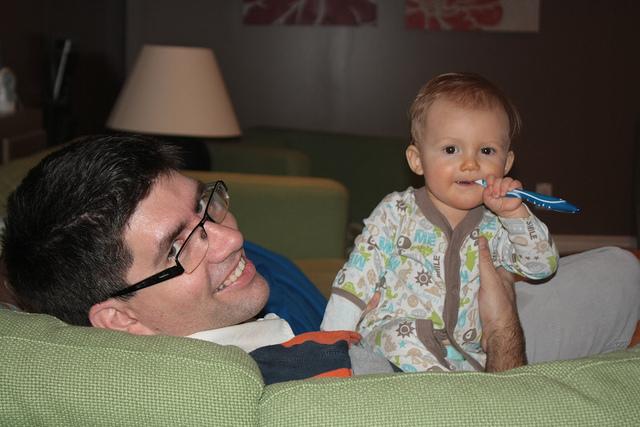What color is the lampshade?
Be succinct. White. What is the baby holding?
Concise answer only. Toothbrush. What is the baby doing?
Write a very short answer. Brushing teeth. What does the man have over his eyes?
Short answer required. Glasses. 